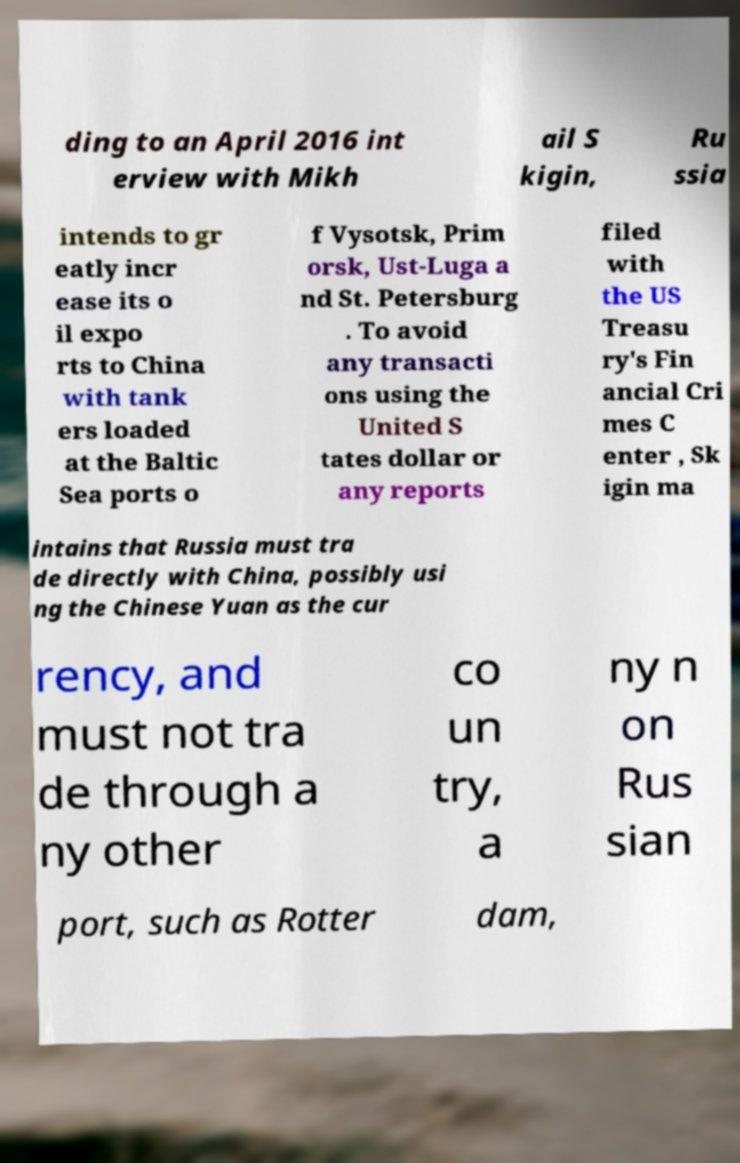For documentation purposes, I need the text within this image transcribed. Could you provide that? ding to an April 2016 int erview with Mikh ail S kigin, Ru ssia intends to gr eatly incr ease its o il expo rts to China with tank ers loaded at the Baltic Sea ports o f Vysotsk, Prim orsk, Ust-Luga a nd St. Petersburg . To avoid any transacti ons using the United S tates dollar or any reports filed with the US Treasu ry's Fin ancial Cri mes C enter , Sk igin ma intains that Russia must tra de directly with China, possibly usi ng the Chinese Yuan as the cur rency, and must not tra de through a ny other co un try, a ny n on Rus sian port, such as Rotter dam, 